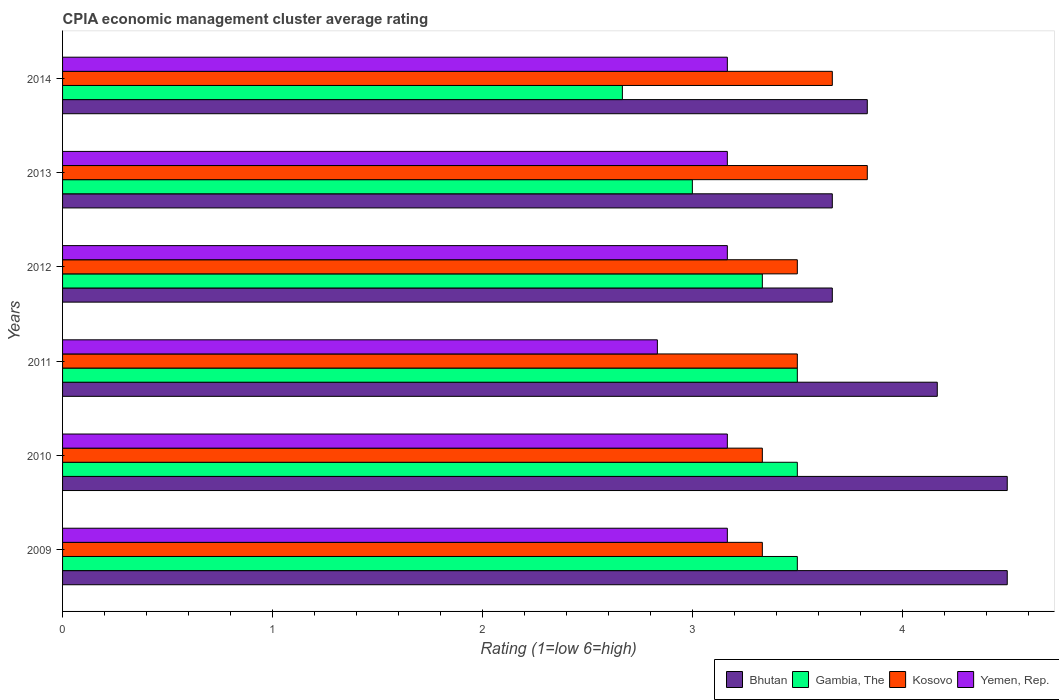Are the number of bars per tick equal to the number of legend labels?
Ensure brevity in your answer.  Yes. How many bars are there on the 2nd tick from the bottom?
Your answer should be compact. 4. What is the CPIA rating in Yemen, Rep. in 2014?
Your answer should be very brief. 3.17. Across all years, what is the maximum CPIA rating in Kosovo?
Your answer should be compact. 3.83. Across all years, what is the minimum CPIA rating in Kosovo?
Provide a short and direct response. 3.33. In which year was the CPIA rating in Kosovo maximum?
Your response must be concise. 2013. What is the total CPIA rating in Kosovo in the graph?
Your answer should be compact. 21.17. What is the difference between the CPIA rating in Bhutan in 2009 and that in 2011?
Give a very brief answer. 0.33. What is the difference between the CPIA rating in Gambia, The in 2010 and the CPIA rating in Kosovo in 2013?
Your answer should be very brief. -0.33. What is the average CPIA rating in Gambia, The per year?
Offer a terse response. 3.25. In the year 2010, what is the difference between the CPIA rating in Bhutan and CPIA rating in Yemen, Rep.?
Your answer should be very brief. 1.33. In how many years, is the CPIA rating in Yemen, Rep. greater than 2.8 ?
Give a very brief answer. 6. What is the ratio of the CPIA rating in Gambia, The in 2011 to that in 2013?
Offer a terse response. 1.17. Is the difference between the CPIA rating in Bhutan in 2012 and 2014 greater than the difference between the CPIA rating in Yemen, Rep. in 2012 and 2014?
Ensure brevity in your answer.  No. What is the difference between the highest and the second highest CPIA rating in Gambia, The?
Offer a very short reply. 0. What is the difference between the highest and the lowest CPIA rating in Bhutan?
Ensure brevity in your answer.  0.83. In how many years, is the CPIA rating in Bhutan greater than the average CPIA rating in Bhutan taken over all years?
Your response must be concise. 3. Is it the case that in every year, the sum of the CPIA rating in Bhutan and CPIA rating in Kosovo is greater than the sum of CPIA rating in Yemen, Rep. and CPIA rating in Gambia, The?
Your answer should be very brief. Yes. What does the 2nd bar from the top in 2009 represents?
Offer a very short reply. Kosovo. What does the 4th bar from the bottom in 2009 represents?
Your answer should be very brief. Yemen, Rep. Are all the bars in the graph horizontal?
Make the answer very short. Yes. How many years are there in the graph?
Your answer should be compact. 6. What is the difference between two consecutive major ticks on the X-axis?
Offer a terse response. 1. Does the graph contain grids?
Your answer should be compact. No. Where does the legend appear in the graph?
Make the answer very short. Bottom right. How are the legend labels stacked?
Offer a terse response. Horizontal. What is the title of the graph?
Ensure brevity in your answer.  CPIA economic management cluster average rating. Does "Ethiopia" appear as one of the legend labels in the graph?
Make the answer very short. No. What is the Rating (1=low 6=high) in Bhutan in 2009?
Your answer should be compact. 4.5. What is the Rating (1=low 6=high) of Gambia, The in 2009?
Offer a terse response. 3.5. What is the Rating (1=low 6=high) in Kosovo in 2009?
Make the answer very short. 3.33. What is the Rating (1=low 6=high) of Yemen, Rep. in 2009?
Give a very brief answer. 3.17. What is the Rating (1=low 6=high) in Bhutan in 2010?
Offer a very short reply. 4.5. What is the Rating (1=low 6=high) of Kosovo in 2010?
Give a very brief answer. 3.33. What is the Rating (1=low 6=high) in Yemen, Rep. in 2010?
Provide a short and direct response. 3.17. What is the Rating (1=low 6=high) of Bhutan in 2011?
Make the answer very short. 4.17. What is the Rating (1=low 6=high) in Yemen, Rep. in 2011?
Ensure brevity in your answer.  2.83. What is the Rating (1=low 6=high) of Bhutan in 2012?
Your response must be concise. 3.67. What is the Rating (1=low 6=high) in Gambia, The in 2012?
Provide a short and direct response. 3.33. What is the Rating (1=low 6=high) in Kosovo in 2012?
Ensure brevity in your answer.  3.5. What is the Rating (1=low 6=high) in Yemen, Rep. in 2012?
Give a very brief answer. 3.17. What is the Rating (1=low 6=high) of Bhutan in 2013?
Make the answer very short. 3.67. What is the Rating (1=low 6=high) of Kosovo in 2013?
Your answer should be very brief. 3.83. What is the Rating (1=low 6=high) of Yemen, Rep. in 2013?
Your response must be concise. 3.17. What is the Rating (1=low 6=high) in Bhutan in 2014?
Provide a short and direct response. 3.83. What is the Rating (1=low 6=high) in Gambia, The in 2014?
Make the answer very short. 2.67. What is the Rating (1=low 6=high) in Kosovo in 2014?
Offer a very short reply. 3.67. What is the Rating (1=low 6=high) in Yemen, Rep. in 2014?
Provide a short and direct response. 3.17. Across all years, what is the maximum Rating (1=low 6=high) of Bhutan?
Keep it short and to the point. 4.5. Across all years, what is the maximum Rating (1=low 6=high) of Kosovo?
Your answer should be compact. 3.83. Across all years, what is the maximum Rating (1=low 6=high) of Yemen, Rep.?
Ensure brevity in your answer.  3.17. Across all years, what is the minimum Rating (1=low 6=high) in Bhutan?
Your response must be concise. 3.67. Across all years, what is the minimum Rating (1=low 6=high) of Gambia, The?
Offer a very short reply. 2.67. Across all years, what is the minimum Rating (1=low 6=high) in Kosovo?
Make the answer very short. 3.33. Across all years, what is the minimum Rating (1=low 6=high) of Yemen, Rep.?
Keep it short and to the point. 2.83. What is the total Rating (1=low 6=high) in Bhutan in the graph?
Keep it short and to the point. 24.33. What is the total Rating (1=low 6=high) in Kosovo in the graph?
Make the answer very short. 21.17. What is the total Rating (1=low 6=high) of Yemen, Rep. in the graph?
Provide a succinct answer. 18.67. What is the difference between the Rating (1=low 6=high) in Bhutan in 2009 and that in 2010?
Offer a terse response. 0. What is the difference between the Rating (1=low 6=high) of Gambia, The in 2009 and that in 2010?
Your answer should be very brief. 0. What is the difference between the Rating (1=low 6=high) of Bhutan in 2009 and that in 2011?
Give a very brief answer. 0.33. What is the difference between the Rating (1=low 6=high) of Kosovo in 2009 and that in 2011?
Provide a succinct answer. -0.17. What is the difference between the Rating (1=low 6=high) in Gambia, The in 2009 and that in 2012?
Your response must be concise. 0.17. What is the difference between the Rating (1=low 6=high) in Bhutan in 2009 and that in 2013?
Offer a very short reply. 0.83. What is the difference between the Rating (1=low 6=high) in Gambia, The in 2009 and that in 2013?
Offer a very short reply. 0.5. What is the difference between the Rating (1=low 6=high) of Kosovo in 2009 and that in 2013?
Ensure brevity in your answer.  -0.5. What is the difference between the Rating (1=low 6=high) of Yemen, Rep. in 2009 and that in 2013?
Make the answer very short. 0. What is the difference between the Rating (1=low 6=high) of Bhutan in 2009 and that in 2014?
Ensure brevity in your answer.  0.67. What is the difference between the Rating (1=low 6=high) in Kosovo in 2009 and that in 2014?
Your answer should be compact. -0.33. What is the difference between the Rating (1=low 6=high) in Yemen, Rep. in 2009 and that in 2014?
Make the answer very short. -0. What is the difference between the Rating (1=low 6=high) in Gambia, The in 2010 and that in 2011?
Offer a terse response. 0. What is the difference between the Rating (1=low 6=high) in Kosovo in 2010 and that in 2011?
Offer a very short reply. -0.17. What is the difference between the Rating (1=low 6=high) in Bhutan in 2010 and that in 2012?
Ensure brevity in your answer.  0.83. What is the difference between the Rating (1=low 6=high) of Gambia, The in 2010 and that in 2012?
Your answer should be very brief. 0.17. What is the difference between the Rating (1=low 6=high) of Kosovo in 2010 and that in 2012?
Make the answer very short. -0.17. What is the difference between the Rating (1=low 6=high) of Gambia, The in 2010 and that in 2013?
Ensure brevity in your answer.  0.5. What is the difference between the Rating (1=low 6=high) of Yemen, Rep. in 2010 and that in 2013?
Provide a short and direct response. 0. What is the difference between the Rating (1=low 6=high) in Yemen, Rep. in 2010 and that in 2014?
Your answer should be very brief. -0. What is the difference between the Rating (1=low 6=high) of Yemen, Rep. in 2011 and that in 2012?
Your answer should be compact. -0.33. What is the difference between the Rating (1=low 6=high) in Yemen, Rep. in 2011 and that in 2013?
Your response must be concise. -0.33. What is the difference between the Rating (1=low 6=high) of Gambia, The in 2011 and that in 2014?
Make the answer very short. 0.83. What is the difference between the Rating (1=low 6=high) in Yemen, Rep. in 2011 and that in 2014?
Offer a terse response. -0.33. What is the difference between the Rating (1=low 6=high) in Gambia, The in 2012 and that in 2013?
Provide a succinct answer. 0.33. What is the difference between the Rating (1=low 6=high) in Kosovo in 2012 and that in 2013?
Ensure brevity in your answer.  -0.33. What is the difference between the Rating (1=low 6=high) of Bhutan in 2012 and that in 2014?
Provide a short and direct response. -0.17. What is the difference between the Rating (1=low 6=high) in Gambia, The in 2012 and that in 2014?
Offer a terse response. 0.67. What is the difference between the Rating (1=low 6=high) of Bhutan in 2013 and that in 2014?
Keep it short and to the point. -0.17. What is the difference between the Rating (1=low 6=high) in Yemen, Rep. in 2013 and that in 2014?
Provide a succinct answer. -0. What is the difference between the Rating (1=low 6=high) of Bhutan in 2009 and the Rating (1=low 6=high) of Gambia, The in 2010?
Your answer should be very brief. 1. What is the difference between the Rating (1=low 6=high) in Gambia, The in 2009 and the Rating (1=low 6=high) in Kosovo in 2010?
Your response must be concise. 0.17. What is the difference between the Rating (1=low 6=high) in Bhutan in 2009 and the Rating (1=low 6=high) in Gambia, The in 2011?
Make the answer very short. 1. What is the difference between the Rating (1=low 6=high) in Bhutan in 2009 and the Rating (1=low 6=high) in Kosovo in 2011?
Offer a very short reply. 1. What is the difference between the Rating (1=low 6=high) in Bhutan in 2009 and the Rating (1=low 6=high) in Yemen, Rep. in 2011?
Offer a terse response. 1.67. What is the difference between the Rating (1=low 6=high) in Gambia, The in 2009 and the Rating (1=low 6=high) in Kosovo in 2011?
Offer a very short reply. 0. What is the difference between the Rating (1=low 6=high) in Kosovo in 2009 and the Rating (1=low 6=high) in Yemen, Rep. in 2011?
Offer a very short reply. 0.5. What is the difference between the Rating (1=low 6=high) of Bhutan in 2009 and the Rating (1=low 6=high) of Gambia, The in 2012?
Your answer should be compact. 1.17. What is the difference between the Rating (1=low 6=high) in Gambia, The in 2009 and the Rating (1=low 6=high) in Kosovo in 2012?
Offer a very short reply. 0. What is the difference between the Rating (1=low 6=high) of Gambia, The in 2009 and the Rating (1=low 6=high) of Yemen, Rep. in 2012?
Ensure brevity in your answer.  0.33. What is the difference between the Rating (1=low 6=high) of Bhutan in 2009 and the Rating (1=low 6=high) of Kosovo in 2013?
Ensure brevity in your answer.  0.67. What is the difference between the Rating (1=low 6=high) of Bhutan in 2009 and the Rating (1=low 6=high) of Yemen, Rep. in 2013?
Offer a very short reply. 1.33. What is the difference between the Rating (1=low 6=high) in Gambia, The in 2009 and the Rating (1=low 6=high) in Yemen, Rep. in 2013?
Offer a very short reply. 0.33. What is the difference between the Rating (1=low 6=high) of Kosovo in 2009 and the Rating (1=low 6=high) of Yemen, Rep. in 2013?
Offer a terse response. 0.17. What is the difference between the Rating (1=low 6=high) in Bhutan in 2009 and the Rating (1=low 6=high) in Gambia, The in 2014?
Your response must be concise. 1.83. What is the difference between the Rating (1=low 6=high) in Bhutan in 2009 and the Rating (1=low 6=high) in Kosovo in 2014?
Offer a terse response. 0.83. What is the difference between the Rating (1=low 6=high) of Gambia, The in 2009 and the Rating (1=low 6=high) of Kosovo in 2014?
Offer a terse response. -0.17. What is the difference between the Rating (1=low 6=high) in Gambia, The in 2009 and the Rating (1=low 6=high) in Yemen, Rep. in 2014?
Ensure brevity in your answer.  0.33. What is the difference between the Rating (1=low 6=high) in Kosovo in 2009 and the Rating (1=low 6=high) in Yemen, Rep. in 2014?
Offer a terse response. 0.17. What is the difference between the Rating (1=low 6=high) in Bhutan in 2010 and the Rating (1=low 6=high) in Yemen, Rep. in 2011?
Your answer should be compact. 1.67. What is the difference between the Rating (1=low 6=high) in Gambia, The in 2010 and the Rating (1=low 6=high) in Kosovo in 2011?
Your response must be concise. 0. What is the difference between the Rating (1=low 6=high) of Kosovo in 2010 and the Rating (1=low 6=high) of Yemen, Rep. in 2011?
Your response must be concise. 0.5. What is the difference between the Rating (1=low 6=high) in Bhutan in 2010 and the Rating (1=low 6=high) in Yemen, Rep. in 2012?
Provide a succinct answer. 1.33. What is the difference between the Rating (1=low 6=high) of Gambia, The in 2010 and the Rating (1=low 6=high) of Kosovo in 2012?
Provide a succinct answer. 0. What is the difference between the Rating (1=low 6=high) of Gambia, The in 2010 and the Rating (1=low 6=high) of Yemen, Rep. in 2012?
Provide a short and direct response. 0.33. What is the difference between the Rating (1=low 6=high) of Kosovo in 2010 and the Rating (1=low 6=high) of Yemen, Rep. in 2012?
Your answer should be compact. 0.17. What is the difference between the Rating (1=low 6=high) in Bhutan in 2010 and the Rating (1=low 6=high) in Kosovo in 2013?
Ensure brevity in your answer.  0.67. What is the difference between the Rating (1=low 6=high) in Gambia, The in 2010 and the Rating (1=low 6=high) in Yemen, Rep. in 2013?
Ensure brevity in your answer.  0.33. What is the difference between the Rating (1=low 6=high) of Bhutan in 2010 and the Rating (1=low 6=high) of Gambia, The in 2014?
Ensure brevity in your answer.  1.83. What is the difference between the Rating (1=low 6=high) in Gambia, The in 2010 and the Rating (1=low 6=high) in Kosovo in 2014?
Give a very brief answer. -0.17. What is the difference between the Rating (1=low 6=high) in Bhutan in 2011 and the Rating (1=low 6=high) in Gambia, The in 2012?
Keep it short and to the point. 0.83. What is the difference between the Rating (1=low 6=high) in Bhutan in 2011 and the Rating (1=low 6=high) in Kosovo in 2012?
Make the answer very short. 0.67. What is the difference between the Rating (1=low 6=high) of Gambia, The in 2011 and the Rating (1=low 6=high) of Yemen, Rep. in 2012?
Your response must be concise. 0.33. What is the difference between the Rating (1=low 6=high) in Bhutan in 2011 and the Rating (1=low 6=high) in Gambia, The in 2013?
Ensure brevity in your answer.  1.17. What is the difference between the Rating (1=low 6=high) of Gambia, The in 2011 and the Rating (1=low 6=high) of Yemen, Rep. in 2013?
Give a very brief answer. 0.33. What is the difference between the Rating (1=low 6=high) in Bhutan in 2011 and the Rating (1=low 6=high) in Gambia, The in 2014?
Ensure brevity in your answer.  1.5. What is the difference between the Rating (1=low 6=high) of Bhutan in 2011 and the Rating (1=low 6=high) of Kosovo in 2014?
Offer a terse response. 0.5. What is the difference between the Rating (1=low 6=high) in Gambia, The in 2011 and the Rating (1=low 6=high) in Yemen, Rep. in 2014?
Give a very brief answer. 0.33. What is the difference between the Rating (1=low 6=high) of Kosovo in 2011 and the Rating (1=low 6=high) of Yemen, Rep. in 2014?
Ensure brevity in your answer.  0.33. What is the difference between the Rating (1=low 6=high) of Bhutan in 2012 and the Rating (1=low 6=high) of Gambia, The in 2013?
Your response must be concise. 0.67. What is the difference between the Rating (1=low 6=high) in Gambia, The in 2012 and the Rating (1=low 6=high) in Kosovo in 2013?
Your response must be concise. -0.5. What is the difference between the Rating (1=low 6=high) in Bhutan in 2012 and the Rating (1=low 6=high) in Gambia, The in 2014?
Offer a terse response. 1. What is the difference between the Rating (1=low 6=high) in Gambia, The in 2012 and the Rating (1=low 6=high) in Kosovo in 2014?
Ensure brevity in your answer.  -0.33. What is the difference between the Rating (1=low 6=high) in Gambia, The in 2012 and the Rating (1=low 6=high) in Yemen, Rep. in 2014?
Provide a short and direct response. 0.17. What is the difference between the Rating (1=low 6=high) in Bhutan in 2013 and the Rating (1=low 6=high) in Kosovo in 2014?
Keep it short and to the point. -0. What is the difference between the Rating (1=low 6=high) in Gambia, The in 2013 and the Rating (1=low 6=high) in Kosovo in 2014?
Offer a very short reply. -0.67. What is the difference between the Rating (1=low 6=high) in Kosovo in 2013 and the Rating (1=low 6=high) in Yemen, Rep. in 2014?
Keep it short and to the point. 0.67. What is the average Rating (1=low 6=high) in Bhutan per year?
Ensure brevity in your answer.  4.06. What is the average Rating (1=low 6=high) of Kosovo per year?
Make the answer very short. 3.53. What is the average Rating (1=low 6=high) in Yemen, Rep. per year?
Provide a short and direct response. 3.11. In the year 2009, what is the difference between the Rating (1=low 6=high) of Bhutan and Rating (1=low 6=high) of Gambia, The?
Offer a terse response. 1. In the year 2009, what is the difference between the Rating (1=low 6=high) of Bhutan and Rating (1=low 6=high) of Kosovo?
Make the answer very short. 1.17. In the year 2009, what is the difference between the Rating (1=low 6=high) of Gambia, The and Rating (1=low 6=high) of Kosovo?
Provide a short and direct response. 0.17. In the year 2009, what is the difference between the Rating (1=low 6=high) of Kosovo and Rating (1=low 6=high) of Yemen, Rep.?
Your answer should be compact. 0.17. In the year 2010, what is the difference between the Rating (1=low 6=high) in Bhutan and Rating (1=low 6=high) in Gambia, The?
Provide a short and direct response. 1. In the year 2010, what is the difference between the Rating (1=low 6=high) in Bhutan and Rating (1=low 6=high) in Yemen, Rep.?
Offer a very short reply. 1.33. In the year 2010, what is the difference between the Rating (1=low 6=high) of Gambia, The and Rating (1=low 6=high) of Yemen, Rep.?
Provide a succinct answer. 0.33. In the year 2010, what is the difference between the Rating (1=low 6=high) of Kosovo and Rating (1=low 6=high) of Yemen, Rep.?
Give a very brief answer. 0.17. In the year 2011, what is the difference between the Rating (1=low 6=high) of Bhutan and Rating (1=low 6=high) of Gambia, The?
Offer a very short reply. 0.67. In the year 2011, what is the difference between the Rating (1=low 6=high) of Bhutan and Rating (1=low 6=high) of Kosovo?
Your answer should be compact. 0.67. In the year 2011, what is the difference between the Rating (1=low 6=high) of Bhutan and Rating (1=low 6=high) of Yemen, Rep.?
Make the answer very short. 1.33. In the year 2011, what is the difference between the Rating (1=low 6=high) in Gambia, The and Rating (1=low 6=high) in Kosovo?
Offer a very short reply. 0. In the year 2011, what is the difference between the Rating (1=low 6=high) in Kosovo and Rating (1=low 6=high) in Yemen, Rep.?
Your answer should be very brief. 0.67. In the year 2012, what is the difference between the Rating (1=low 6=high) of Bhutan and Rating (1=low 6=high) of Yemen, Rep.?
Provide a succinct answer. 0.5. In the year 2012, what is the difference between the Rating (1=low 6=high) of Gambia, The and Rating (1=low 6=high) of Yemen, Rep.?
Keep it short and to the point. 0.17. In the year 2013, what is the difference between the Rating (1=low 6=high) in Bhutan and Rating (1=low 6=high) in Kosovo?
Your answer should be very brief. -0.17. In the year 2013, what is the difference between the Rating (1=low 6=high) of Bhutan and Rating (1=low 6=high) of Yemen, Rep.?
Provide a succinct answer. 0.5. In the year 2013, what is the difference between the Rating (1=low 6=high) of Gambia, The and Rating (1=low 6=high) of Yemen, Rep.?
Your response must be concise. -0.17. In the year 2013, what is the difference between the Rating (1=low 6=high) in Kosovo and Rating (1=low 6=high) in Yemen, Rep.?
Ensure brevity in your answer.  0.67. In the year 2014, what is the difference between the Rating (1=low 6=high) of Bhutan and Rating (1=low 6=high) of Gambia, The?
Provide a short and direct response. 1.17. In the year 2014, what is the difference between the Rating (1=low 6=high) of Kosovo and Rating (1=low 6=high) of Yemen, Rep.?
Give a very brief answer. 0.5. What is the ratio of the Rating (1=low 6=high) of Yemen, Rep. in 2009 to that in 2010?
Your answer should be compact. 1. What is the ratio of the Rating (1=low 6=high) in Kosovo in 2009 to that in 2011?
Your answer should be compact. 0.95. What is the ratio of the Rating (1=low 6=high) in Yemen, Rep. in 2009 to that in 2011?
Ensure brevity in your answer.  1.12. What is the ratio of the Rating (1=low 6=high) in Bhutan in 2009 to that in 2012?
Ensure brevity in your answer.  1.23. What is the ratio of the Rating (1=low 6=high) of Yemen, Rep. in 2009 to that in 2012?
Provide a succinct answer. 1. What is the ratio of the Rating (1=low 6=high) in Bhutan in 2009 to that in 2013?
Make the answer very short. 1.23. What is the ratio of the Rating (1=low 6=high) in Gambia, The in 2009 to that in 2013?
Your answer should be very brief. 1.17. What is the ratio of the Rating (1=low 6=high) in Kosovo in 2009 to that in 2013?
Keep it short and to the point. 0.87. What is the ratio of the Rating (1=low 6=high) of Bhutan in 2009 to that in 2014?
Keep it short and to the point. 1.17. What is the ratio of the Rating (1=low 6=high) in Gambia, The in 2009 to that in 2014?
Provide a short and direct response. 1.31. What is the ratio of the Rating (1=low 6=high) of Gambia, The in 2010 to that in 2011?
Give a very brief answer. 1. What is the ratio of the Rating (1=low 6=high) of Kosovo in 2010 to that in 2011?
Keep it short and to the point. 0.95. What is the ratio of the Rating (1=low 6=high) of Yemen, Rep. in 2010 to that in 2011?
Ensure brevity in your answer.  1.12. What is the ratio of the Rating (1=low 6=high) of Bhutan in 2010 to that in 2012?
Ensure brevity in your answer.  1.23. What is the ratio of the Rating (1=low 6=high) in Gambia, The in 2010 to that in 2012?
Offer a terse response. 1.05. What is the ratio of the Rating (1=low 6=high) in Yemen, Rep. in 2010 to that in 2012?
Keep it short and to the point. 1. What is the ratio of the Rating (1=low 6=high) in Bhutan in 2010 to that in 2013?
Your answer should be compact. 1.23. What is the ratio of the Rating (1=low 6=high) in Kosovo in 2010 to that in 2013?
Offer a terse response. 0.87. What is the ratio of the Rating (1=low 6=high) in Yemen, Rep. in 2010 to that in 2013?
Your answer should be compact. 1. What is the ratio of the Rating (1=low 6=high) in Bhutan in 2010 to that in 2014?
Your answer should be compact. 1.17. What is the ratio of the Rating (1=low 6=high) in Gambia, The in 2010 to that in 2014?
Make the answer very short. 1.31. What is the ratio of the Rating (1=low 6=high) in Kosovo in 2010 to that in 2014?
Your answer should be compact. 0.91. What is the ratio of the Rating (1=low 6=high) of Yemen, Rep. in 2010 to that in 2014?
Ensure brevity in your answer.  1. What is the ratio of the Rating (1=low 6=high) in Bhutan in 2011 to that in 2012?
Keep it short and to the point. 1.14. What is the ratio of the Rating (1=low 6=high) in Kosovo in 2011 to that in 2012?
Your answer should be compact. 1. What is the ratio of the Rating (1=low 6=high) of Yemen, Rep. in 2011 to that in 2012?
Your answer should be compact. 0.89. What is the ratio of the Rating (1=low 6=high) in Bhutan in 2011 to that in 2013?
Ensure brevity in your answer.  1.14. What is the ratio of the Rating (1=low 6=high) in Kosovo in 2011 to that in 2013?
Provide a short and direct response. 0.91. What is the ratio of the Rating (1=low 6=high) of Yemen, Rep. in 2011 to that in 2013?
Your response must be concise. 0.89. What is the ratio of the Rating (1=low 6=high) in Bhutan in 2011 to that in 2014?
Offer a terse response. 1.09. What is the ratio of the Rating (1=low 6=high) of Gambia, The in 2011 to that in 2014?
Give a very brief answer. 1.31. What is the ratio of the Rating (1=low 6=high) in Kosovo in 2011 to that in 2014?
Offer a terse response. 0.95. What is the ratio of the Rating (1=low 6=high) of Yemen, Rep. in 2011 to that in 2014?
Your answer should be compact. 0.89. What is the ratio of the Rating (1=low 6=high) in Bhutan in 2012 to that in 2014?
Your answer should be very brief. 0.96. What is the ratio of the Rating (1=low 6=high) of Kosovo in 2012 to that in 2014?
Provide a succinct answer. 0.95. What is the ratio of the Rating (1=low 6=high) of Bhutan in 2013 to that in 2014?
Offer a very short reply. 0.96. What is the ratio of the Rating (1=low 6=high) of Gambia, The in 2013 to that in 2014?
Provide a short and direct response. 1.12. What is the ratio of the Rating (1=low 6=high) of Kosovo in 2013 to that in 2014?
Give a very brief answer. 1.05. What is the ratio of the Rating (1=low 6=high) of Yemen, Rep. in 2013 to that in 2014?
Provide a succinct answer. 1. What is the difference between the highest and the second highest Rating (1=low 6=high) in Gambia, The?
Your response must be concise. 0. What is the difference between the highest and the second highest Rating (1=low 6=high) of Kosovo?
Keep it short and to the point. 0.17. What is the difference between the highest and the lowest Rating (1=low 6=high) in Bhutan?
Your answer should be very brief. 0.83. What is the difference between the highest and the lowest Rating (1=low 6=high) of Gambia, The?
Your answer should be compact. 0.83. What is the difference between the highest and the lowest Rating (1=low 6=high) of Kosovo?
Your answer should be compact. 0.5. 